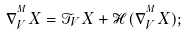Convert formula to latex. <formula><loc_0><loc_0><loc_500><loc_500>\nabla ^ { ^ { M } } _ { V } X = \mathcal { T } _ { V } X + \mathcal { H } ( \nabla ^ { ^ { M } } _ { V } X ) ;</formula> 